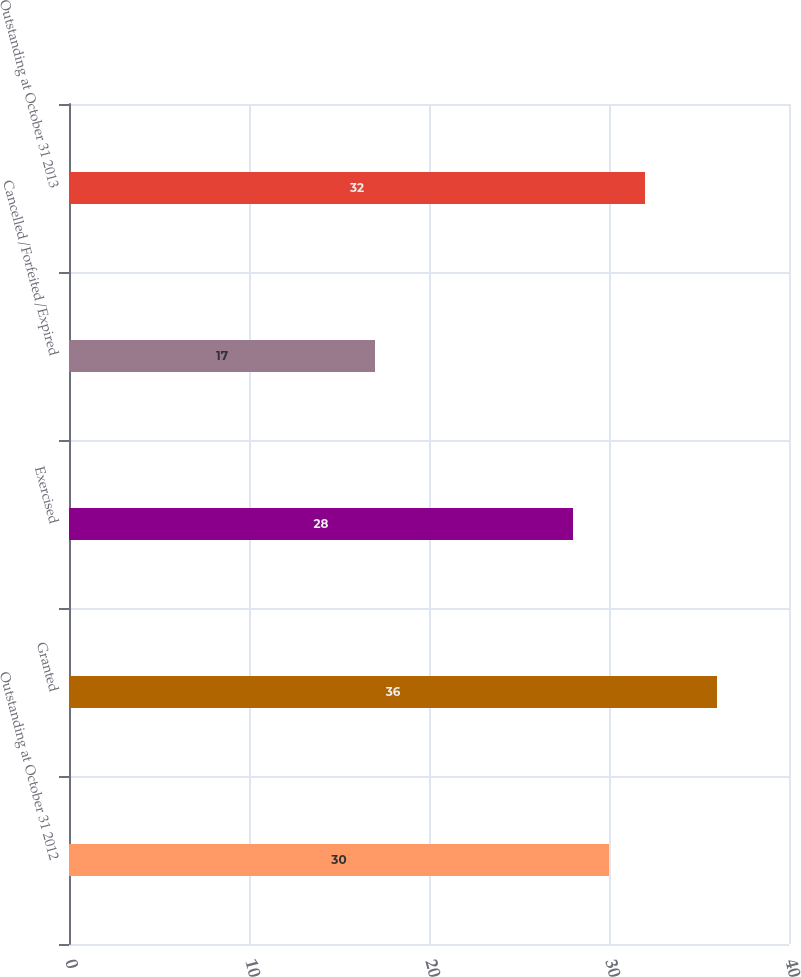Convert chart. <chart><loc_0><loc_0><loc_500><loc_500><bar_chart><fcel>Outstanding at October 31 2012<fcel>Granted<fcel>Exercised<fcel>Cancelled/Forfeited/Expired<fcel>Outstanding at October 31 2013<nl><fcel>30<fcel>36<fcel>28<fcel>17<fcel>32<nl></chart> 